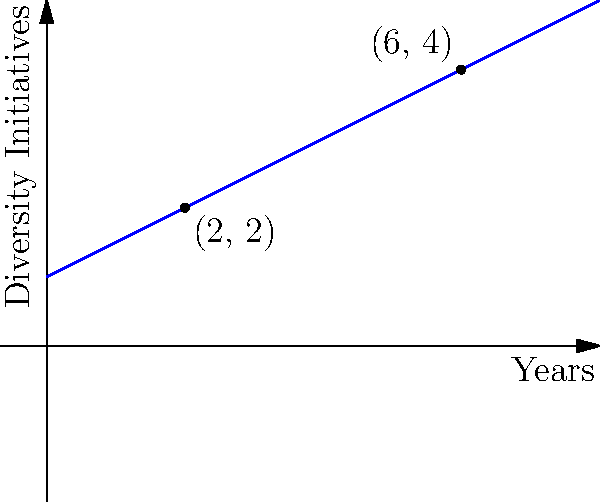A company tracks the number of diversity initiatives implemented over time. The graph shows the trend line of these initiatives. Using the two points (2, 2) and (6, 4), calculate the slope of this line. What does this slope represent in the context of diversity initiatives? To calculate the slope of the line, we'll use the slope formula:

$$ m = \frac{y_2 - y_1}{x_2 - x_1} $$

Where $(x_1, y_1)$ is the first point and $(x_2, y_2)$ is the second point.

Given points: (2, 2) and (6, 4)

Step 1: Identify the coordinates
$x_1 = 2$, $y_1 = 2$
$x_2 = 6$, $y_2 = 4$

Step 2: Apply the slope formula
$$ m = \frac{4 - 2}{6 - 2} = \frac{2}{4} = 0.5 $$

Step 3: Interpret the result
The slope of 0.5 means that for every 1 unit increase in x (1 year), y increases by 0.5 units (0.5 diversity initiatives).

In the context of diversity initiatives, this slope represents the rate at which new diversity initiatives are being implemented over time. Specifically, it indicates that the company is adding an average of 0.5 new diversity initiatives per year.
Answer: 0.5 initiatives per year 